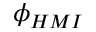<formula> <loc_0><loc_0><loc_500><loc_500>\phi _ { H M I }</formula> 